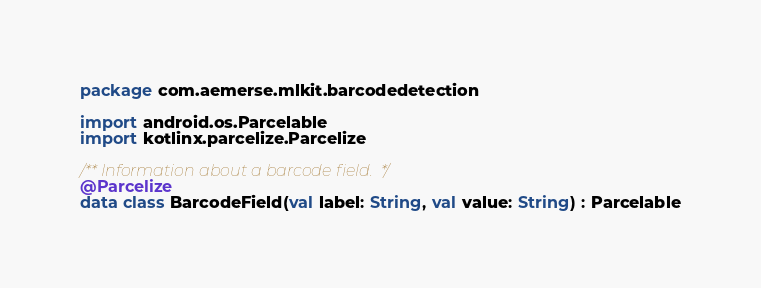<code> <loc_0><loc_0><loc_500><loc_500><_Kotlin_>package com.aemerse.mlkit.barcodedetection

import android.os.Parcelable
import kotlinx.parcelize.Parcelize

/** Information about a barcode field.  */
@Parcelize
data class BarcodeField(val label: String, val value: String) : Parcelable
</code> 